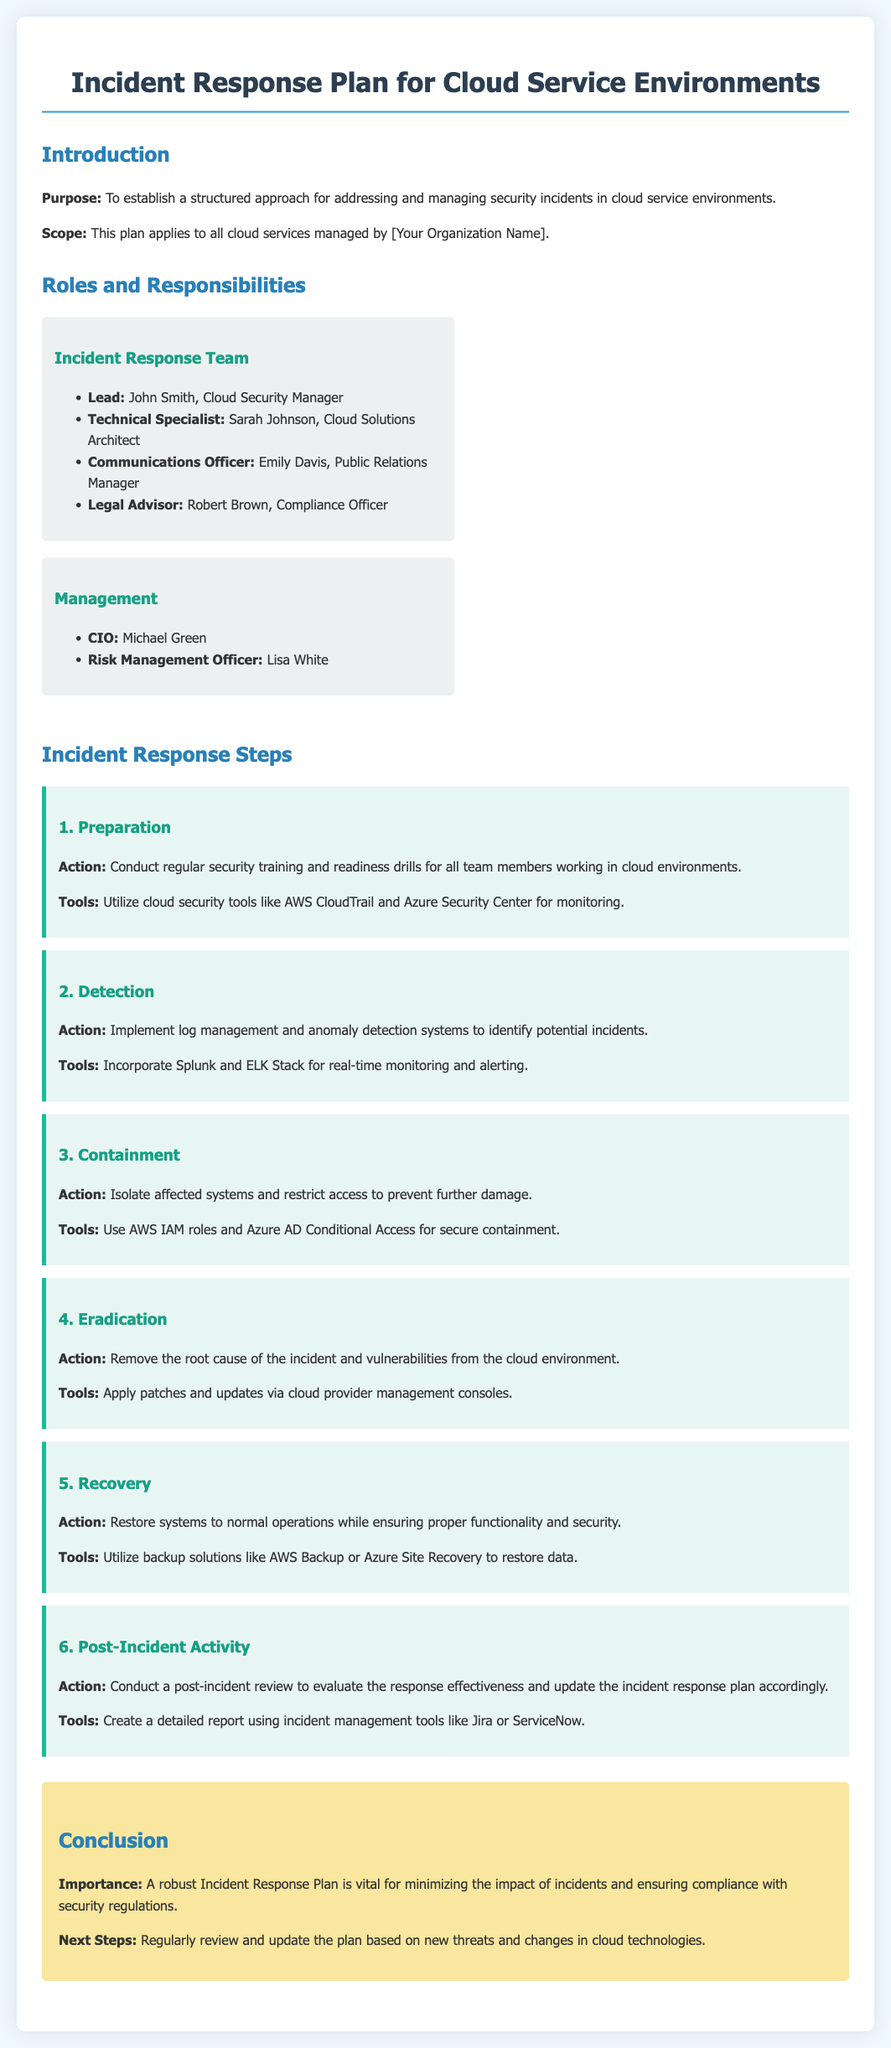What is the purpose of the Incident Response Plan? The purpose is to establish a structured approach for addressing and managing security incidents in cloud service environments.
Answer: To establish a structured approach for addressing and managing security incidents in cloud service environments Who is the lead of the Incident Response Team? The lead is specified in the roles and responsibilities section of the document.
Answer: John Smith Which tool is suggested for implementing log management? The document lists specific tools for detection and monitoring systems.
Answer: Splunk What is the first step in the Incident Response Steps? The steps are outlined in a sequential order, starting from preparation.
Answer: Preparation Who is responsible for legal advice in the Incident Response Team? The roles section specifies who takes on the legal advisor role.
Answer: Robert Brown What is the action to be taken during the containment step? This action involves isolating affected systems to prevent further damage.
Answer: Isolate affected systems What is emphasized as important in the conclusion? The conclusion highlights the importance of a specific aspect of the Incident Response Plan.
Answer: Minimizing the impact of incidents What is the title of the document? The title is stated at the top of the document.
Answer: Incident Response Plan for Cloud Service Environments 